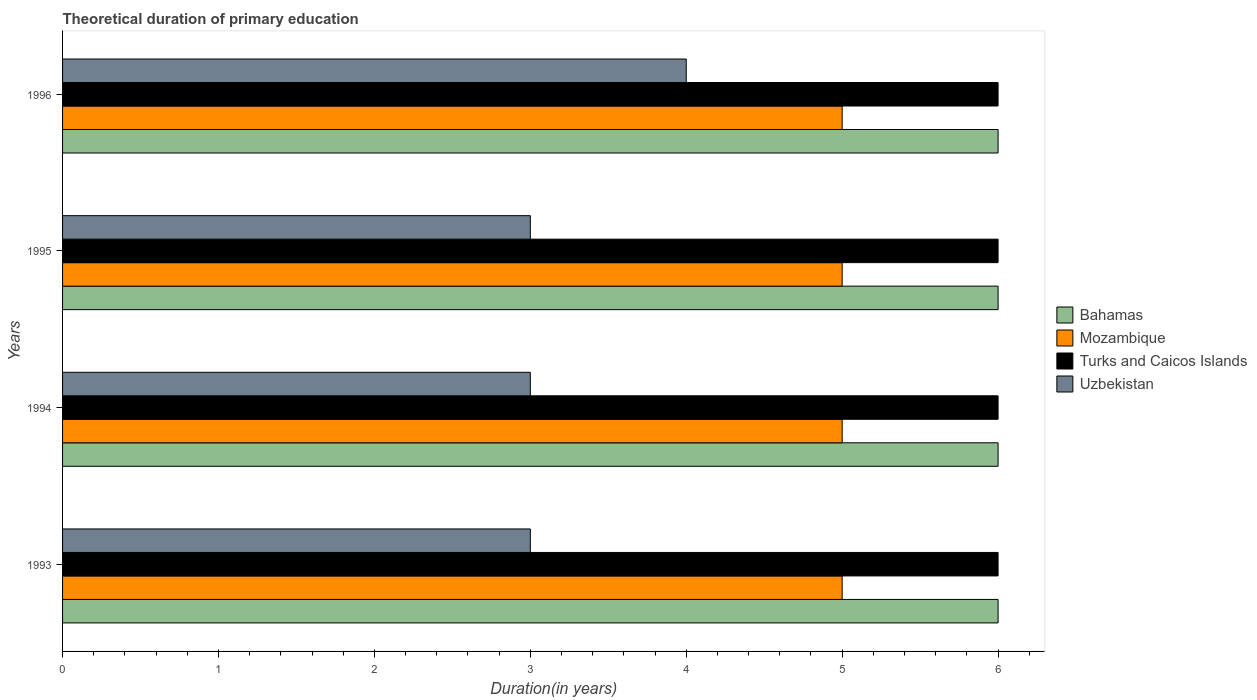How many groups of bars are there?
Give a very brief answer. 4. Are the number of bars per tick equal to the number of legend labels?
Make the answer very short. Yes. Are the number of bars on each tick of the Y-axis equal?
Ensure brevity in your answer.  Yes. How many bars are there on the 4th tick from the bottom?
Your response must be concise. 4. What is the label of the 3rd group of bars from the top?
Provide a short and direct response. 1994. In how many cases, is the number of bars for a given year not equal to the number of legend labels?
Your answer should be very brief. 0. What is the total theoretical duration of primary education in Mozambique in 1994?
Provide a succinct answer. 5. In which year was the total theoretical duration of primary education in Bahamas maximum?
Keep it short and to the point. 1993. In which year was the total theoretical duration of primary education in Bahamas minimum?
Provide a succinct answer. 1993. What is the total total theoretical duration of primary education in Mozambique in the graph?
Offer a very short reply. 20. What is the difference between the total theoretical duration of primary education in Mozambique in 1993 and that in 1994?
Ensure brevity in your answer.  0. What is the difference between the total theoretical duration of primary education in Uzbekistan in 1996 and the total theoretical duration of primary education in Mozambique in 1995?
Provide a short and direct response. -1. What is the average total theoretical duration of primary education in Turks and Caicos Islands per year?
Provide a short and direct response. 6. In the year 1993, what is the difference between the total theoretical duration of primary education in Bahamas and total theoretical duration of primary education in Mozambique?
Your answer should be very brief. 1. In how many years, is the total theoretical duration of primary education in Uzbekistan greater than 3.4 years?
Provide a succinct answer. 1. Is the difference between the total theoretical duration of primary education in Bahamas in 1995 and 1996 greater than the difference between the total theoretical duration of primary education in Mozambique in 1995 and 1996?
Provide a succinct answer. No. What is the difference between the highest and the second highest total theoretical duration of primary education in Bahamas?
Your answer should be compact. 0. What is the difference between the highest and the lowest total theoretical duration of primary education in Turks and Caicos Islands?
Ensure brevity in your answer.  0. In how many years, is the total theoretical duration of primary education in Mozambique greater than the average total theoretical duration of primary education in Mozambique taken over all years?
Your response must be concise. 0. Is the sum of the total theoretical duration of primary education in Mozambique in 1994 and 1995 greater than the maximum total theoretical duration of primary education in Bahamas across all years?
Provide a succinct answer. Yes. Is it the case that in every year, the sum of the total theoretical duration of primary education in Turks and Caicos Islands and total theoretical duration of primary education in Mozambique is greater than the sum of total theoretical duration of primary education in Bahamas and total theoretical duration of primary education in Uzbekistan?
Provide a succinct answer. Yes. What does the 2nd bar from the top in 1994 represents?
Your response must be concise. Turks and Caicos Islands. What does the 2nd bar from the bottom in 1995 represents?
Make the answer very short. Mozambique. Is it the case that in every year, the sum of the total theoretical duration of primary education in Uzbekistan and total theoretical duration of primary education in Mozambique is greater than the total theoretical duration of primary education in Bahamas?
Give a very brief answer. Yes. How many bars are there?
Make the answer very short. 16. Are all the bars in the graph horizontal?
Provide a short and direct response. Yes. How many years are there in the graph?
Make the answer very short. 4. What is the difference between two consecutive major ticks on the X-axis?
Ensure brevity in your answer.  1. Does the graph contain grids?
Offer a very short reply. No. Where does the legend appear in the graph?
Offer a terse response. Center right. How many legend labels are there?
Offer a terse response. 4. What is the title of the graph?
Provide a short and direct response. Theoretical duration of primary education. What is the label or title of the X-axis?
Provide a short and direct response. Duration(in years). What is the label or title of the Y-axis?
Provide a short and direct response. Years. What is the Duration(in years) of Turks and Caicos Islands in 1993?
Provide a succinct answer. 6. What is the Duration(in years) in Uzbekistan in 1993?
Make the answer very short. 3. What is the Duration(in years) in Bahamas in 1994?
Provide a succinct answer. 6. What is the Duration(in years) in Turks and Caicos Islands in 1995?
Offer a terse response. 6. What is the Duration(in years) of Uzbekistan in 1995?
Offer a terse response. 3. What is the Duration(in years) of Mozambique in 1996?
Make the answer very short. 5. Across all years, what is the maximum Duration(in years) in Bahamas?
Make the answer very short. 6. Across all years, what is the maximum Duration(in years) in Mozambique?
Your response must be concise. 5. Across all years, what is the maximum Duration(in years) of Turks and Caicos Islands?
Provide a short and direct response. 6. Across all years, what is the maximum Duration(in years) of Uzbekistan?
Provide a short and direct response. 4. Across all years, what is the minimum Duration(in years) of Bahamas?
Give a very brief answer. 6. Across all years, what is the minimum Duration(in years) of Mozambique?
Your response must be concise. 5. What is the total Duration(in years) of Bahamas in the graph?
Ensure brevity in your answer.  24. What is the difference between the Duration(in years) of Turks and Caicos Islands in 1993 and that in 1994?
Give a very brief answer. 0. What is the difference between the Duration(in years) in Uzbekistan in 1993 and that in 1994?
Your response must be concise. 0. What is the difference between the Duration(in years) of Turks and Caicos Islands in 1993 and that in 1995?
Offer a terse response. 0. What is the difference between the Duration(in years) in Turks and Caicos Islands in 1993 and that in 1996?
Your answer should be compact. 0. What is the difference between the Duration(in years) of Uzbekistan in 1993 and that in 1996?
Your answer should be very brief. -1. What is the difference between the Duration(in years) in Bahamas in 1994 and that in 1995?
Make the answer very short. 0. What is the difference between the Duration(in years) of Mozambique in 1994 and that in 1995?
Make the answer very short. 0. What is the difference between the Duration(in years) in Turks and Caicos Islands in 1994 and that in 1995?
Make the answer very short. 0. What is the difference between the Duration(in years) of Bahamas in 1994 and that in 1996?
Give a very brief answer. 0. What is the difference between the Duration(in years) of Mozambique in 1994 and that in 1996?
Keep it short and to the point. 0. What is the difference between the Duration(in years) in Turks and Caicos Islands in 1994 and that in 1996?
Give a very brief answer. 0. What is the difference between the Duration(in years) in Turks and Caicos Islands in 1995 and that in 1996?
Your answer should be compact. 0. What is the difference between the Duration(in years) in Uzbekistan in 1995 and that in 1996?
Keep it short and to the point. -1. What is the difference between the Duration(in years) in Bahamas in 1993 and the Duration(in years) in Turks and Caicos Islands in 1994?
Make the answer very short. 0. What is the difference between the Duration(in years) in Mozambique in 1993 and the Duration(in years) in Uzbekistan in 1994?
Provide a succinct answer. 2. What is the difference between the Duration(in years) of Turks and Caicos Islands in 1993 and the Duration(in years) of Uzbekistan in 1994?
Keep it short and to the point. 3. What is the difference between the Duration(in years) in Bahamas in 1993 and the Duration(in years) in Mozambique in 1995?
Provide a short and direct response. 1. What is the difference between the Duration(in years) of Mozambique in 1993 and the Duration(in years) of Turks and Caicos Islands in 1995?
Your answer should be very brief. -1. What is the difference between the Duration(in years) in Bahamas in 1993 and the Duration(in years) in Mozambique in 1996?
Ensure brevity in your answer.  1. What is the difference between the Duration(in years) of Bahamas in 1993 and the Duration(in years) of Turks and Caicos Islands in 1996?
Keep it short and to the point. 0. What is the difference between the Duration(in years) of Bahamas in 1993 and the Duration(in years) of Uzbekistan in 1996?
Offer a very short reply. 2. What is the difference between the Duration(in years) of Bahamas in 1994 and the Duration(in years) of Mozambique in 1995?
Make the answer very short. 1. What is the difference between the Duration(in years) in Bahamas in 1994 and the Duration(in years) in Uzbekistan in 1995?
Ensure brevity in your answer.  3. What is the difference between the Duration(in years) of Bahamas in 1994 and the Duration(in years) of Mozambique in 1996?
Your answer should be very brief. 1. What is the difference between the Duration(in years) in Bahamas in 1994 and the Duration(in years) in Uzbekistan in 1996?
Offer a terse response. 2. What is the difference between the Duration(in years) of Mozambique in 1994 and the Duration(in years) of Turks and Caicos Islands in 1996?
Provide a short and direct response. -1. What is the difference between the Duration(in years) of Mozambique in 1994 and the Duration(in years) of Uzbekistan in 1996?
Provide a short and direct response. 1. What is the difference between the Duration(in years) in Bahamas in 1995 and the Duration(in years) in Mozambique in 1996?
Provide a succinct answer. 1. What is the difference between the Duration(in years) of Bahamas in 1995 and the Duration(in years) of Uzbekistan in 1996?
Your answer should be very brief. 2. What is the difference between the Duration(in years) in Mozambique in 1995 and the Duration(in years) in Turks and Caicos Islands in 1996?
Offer a very short reply. -1. What is the difference between the Duration(in years) of Turks and Caicos Islands in 1995 and the Duration(in years) of Uzbekistan in 1996?
Offer a terse response. 2. What is the average Duration(in years) in Mozambique per year?
Your answer should be very brief. 5. What is the average Duration(in years) in Uzbekistan per year?
Your answer should be very brief. 3.25. In the year 1993, what is the difference between the Duration(in years) of Mozambique and Duration(in years) of Turks and Caicos Islands?
Make the answer very short. -1. In the year 1993, what is the difference between the Duration(in years) of Turks and Caicos Islands and Duration(in years) of Uzbekistan?
Provide a short and direct response. 3. In the year 1994, what is the difference between the Duration(in years) of Bahamas and Duration(in years) of Mozambique?
Give a very brief answer. 1. In the year 1994, what is the difference between the Duration(in years) of Bahamas and Duration(in years) of Turks and Caicos Islands?
Offer a terse response. 0. In the year 1994, what is the difference between the Duration(in years) in Bahamas and Duration(in years) in Uzbekistan?
Provide a succinct answer. 3. In the year 1994, what is the difference between the Duration(in years) in Turks and Caicos Islands and Duration(in years) in Uzbekistan?
Offer a terse response. 3. In the year 1995, what is the difference between the Duration(in years) in Bahamas and Duration(in years) in Mozambique?
Make the answer very short. 1. In the year 1995, what is the difference between the Duration(in years) of Bahamas and Duration(in years) of Turks and Caicos Islands?
Your answer should be very brief. 0. In the year 1995, what is the difference between the Duration(in years) in Mozambique and Duration(in years) in Turks and Caicos Islands?
Give a very brief answer. -1. In the year 1995, what is the difference between the Duration(in years) of Turks and Caicos Islands and Duration(in years) of Uzbekistan?
Provide a short and direct response. 3. In the year 1996, what is the difference between the Duration(in years) of Bahamas and Duration(in years) of Mozambique?
Provide a succinct answer. 1. In the year 1996, what is the difference between the Duration(in years) in Bahamas and Duration(in years) in Uzbekistan?
Ensure brevity in your answer.  2. In the year 1996, what is the difference between the Duration(in years) of Mozambique and Duration(in years) of Turks and Caicos Islands?
Your answer should be compact. -1. What is the ratio of the Duration(in years) in Mozambique in 1993 to that in 1994?
Provide a succinct answer. 1. What is the ratio of the Duration(in years) of Uzbekistan in 1993 to that in 1994?
Your answer should be compact. 1. What is the ratio of the Duration(in years) in Uzbekistan in 1993 to that in 1995?
Keep it short and to the point. 1. What is the ratio of the Duration(in years) in Bahamas in 1993 to that in 1996?
Provide a short and direct response. 1. What is the ratio of the Duration(in years) of Mozambique in 1993 to that in 1996?
Make the answer very short. 1. What is the ratio of the Duration(in years) in Turks and Caicos Islands in 1993 to that in 1996?
Offer a very short reply. 1. What is the ratio of the Duration(in years) in Bahamas in 1994 to that in 1995?
Provide a short and direct response. 1. What is the ratio of the Duration(in years) of Turks and Caicos Islands in 1994 to that in 1995?
Provide a short and direct response. 1. What is the ratio of the Duration(in years) in Bahamas in 1994 to that in 1996?
Ensure brevity in your answer.  1. What is the ratio of the Duration(in years) in Mozambique in 1994 to that in 1996?
Offer a very short reply. 1. What is the ratio of the Duration(in years) of Turks and Caicos Islands in 1994 to that in 1996?
Make the answer very short. 1. What is the ratio of the Duration(in years) in Uzbekistan in 1994 to that in 1996?
Your response must be concise. 0.75. What is the ratio of the Duration(in years) of Bahamas in 1995 to that in 1996?
Your answer should be compact. 1. What is the ratio of the Duration(in years) in Mozambique in 1995 to that in 1996?
Provide a short and direct response. 1. What is the ratio of the Duration(in years) in Uzbekistan in 1995 to that in 1996?
Provide a succinct answer. 0.75. What is the difference between the highest and the second highest Duration(in years) of Bahamas?
Ensure brevity in your answer.  0. What is the difference between the highest and the second highest Duration(in years) of Mozambique?
Give a very brief answer. 0. What is the difference between the highest and the second highest Duration(in years) of Turks and Caicos Islands?
Provide a short and direct response. 0. What is the difference between the highest and the lowest Duration(in years) of Mozambique?
Your answer should be very brief. 0. 